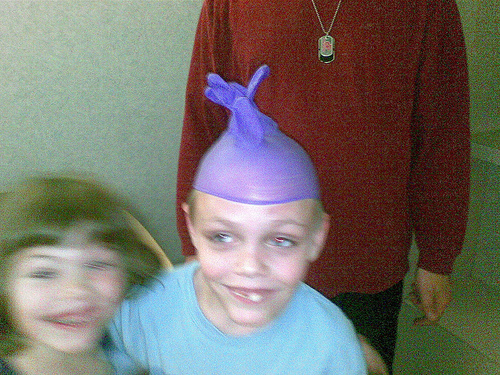<image>
Is the rubber glove above the head? Yes. The rubber glove is positioned above the head in the vertical space, higher up in the scene. 